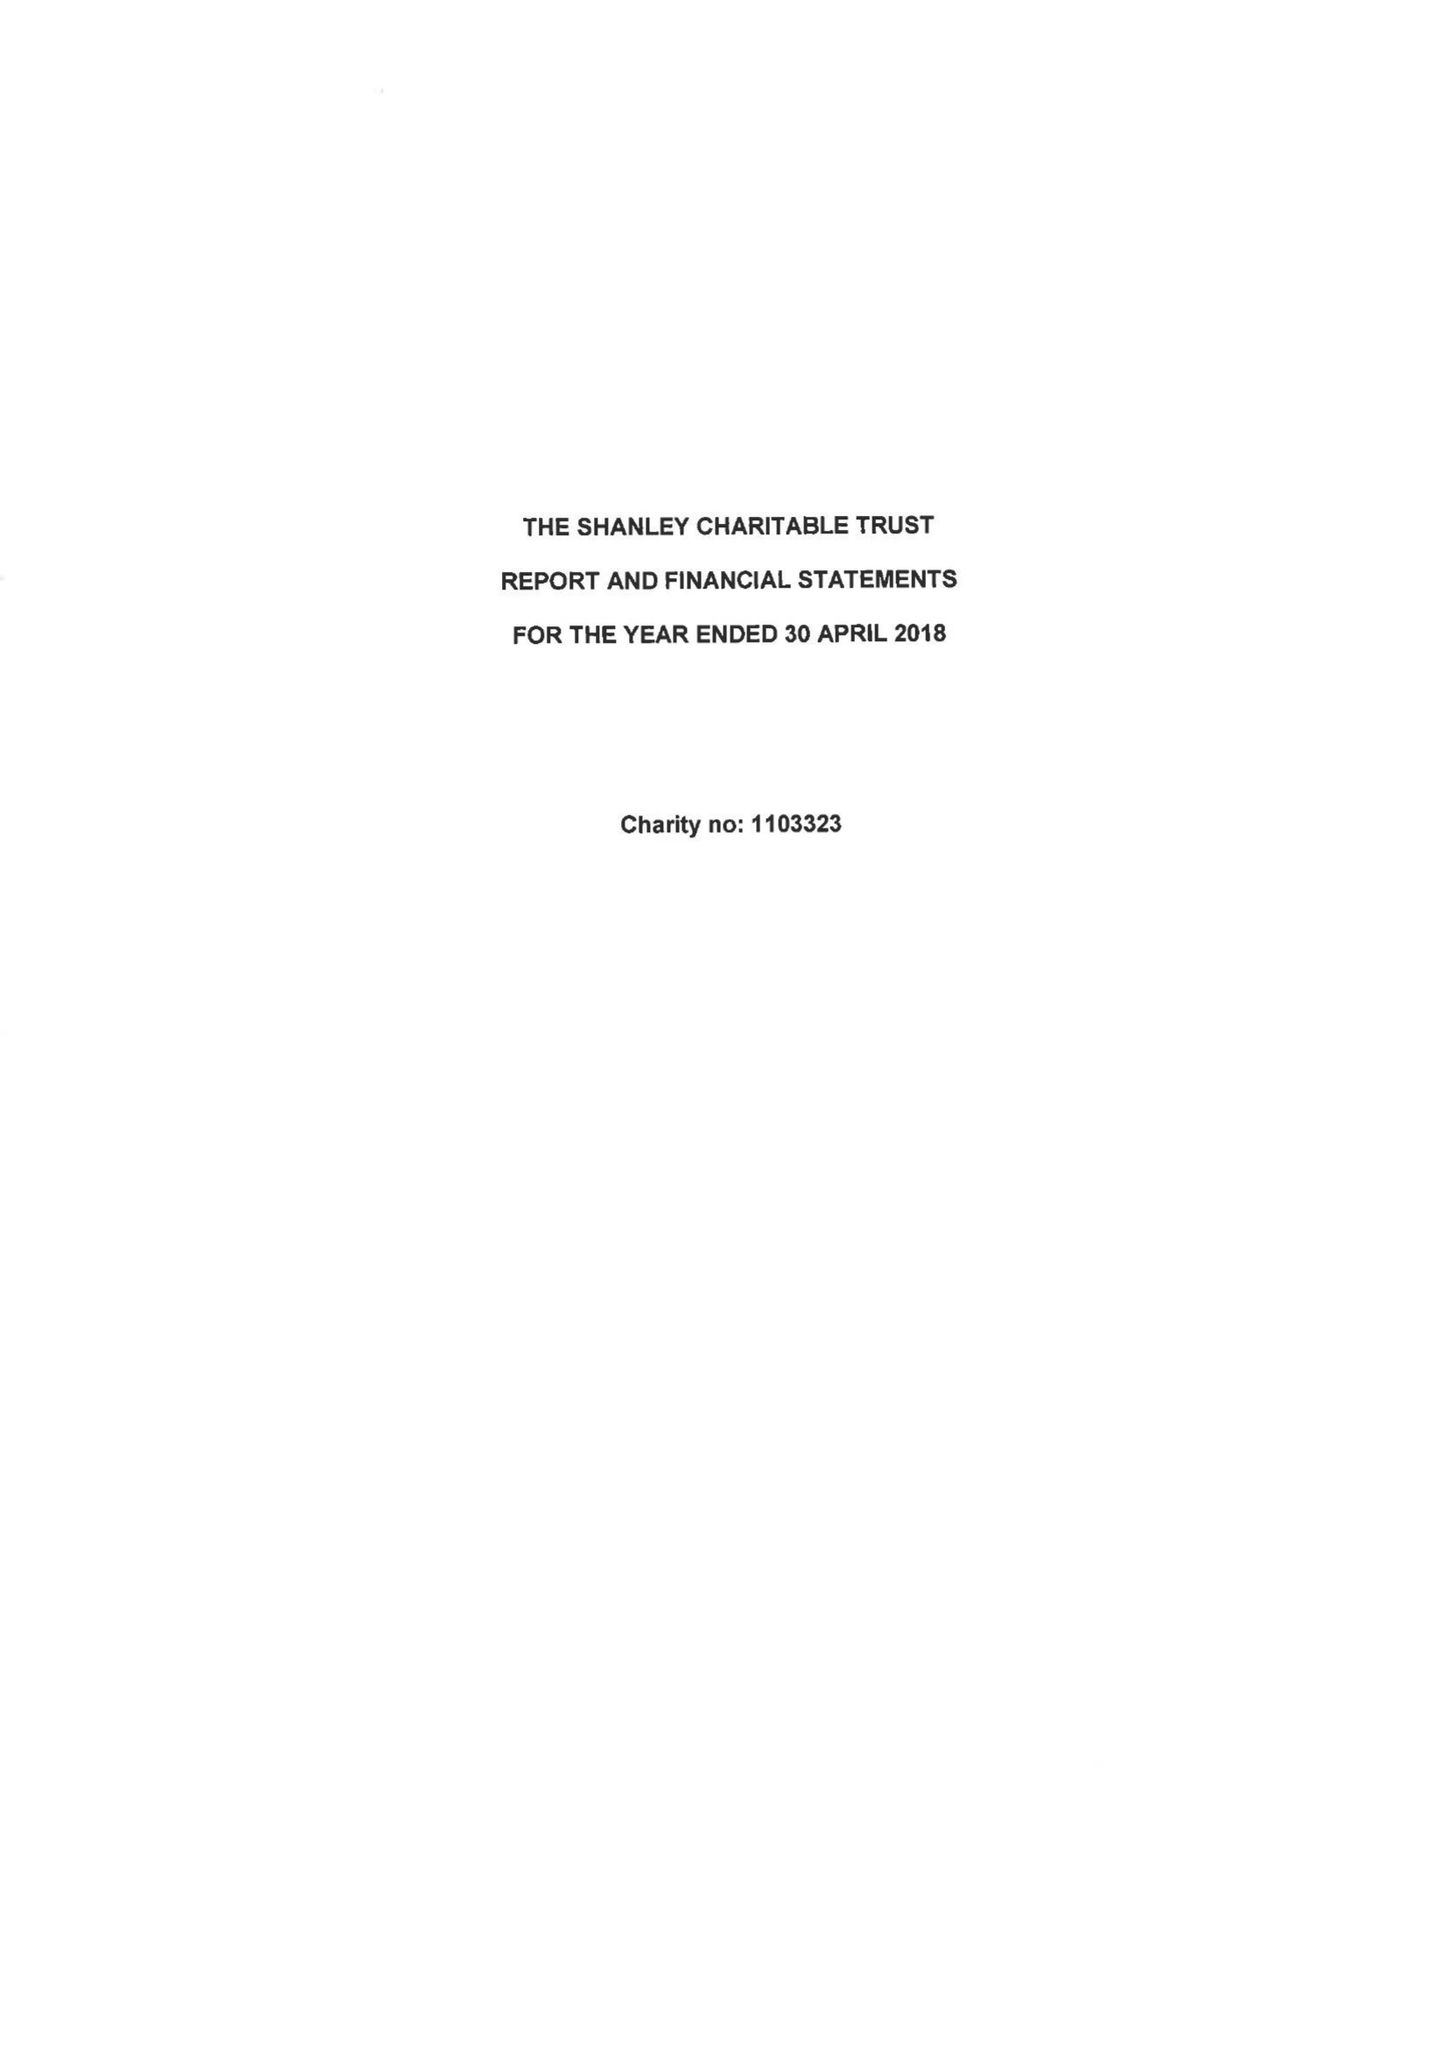What is the value for the charity_name?
Answer the question using a single word or phrase. The Shanley Charitable Trust 